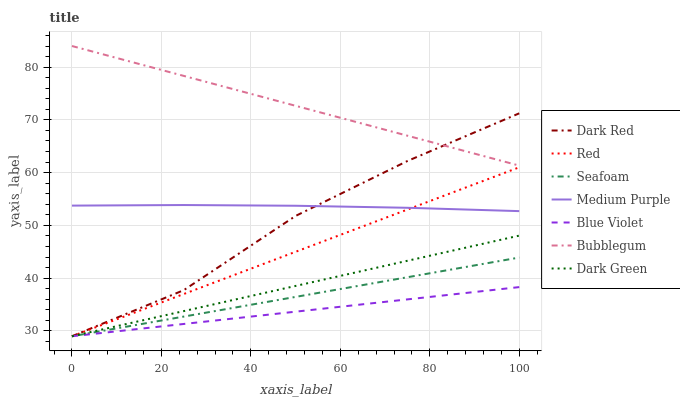Does Blue Violet have the minimum area under the curve?
Answer yes or no. Yes. Does Bubblegum have the maximum area under the curve?
Answer yes or no. Yes. Does Seafoam have the minimum area under the curve?
Answer yes or no. No. Does Seafoam have the maximum area under the curve?
Answer yes or no. No. Is Dark Green the smoothest?
Answer yes or no. Yes. Is Dark Red the roughest?
Answer yes or no. Yes. Is Seafoam the smoothest?
Answer yes or no. No. Is Seafoam the roughest?
Answer yes or no. No. Does Bubblegum have the lowest value?
Answer yes or no. No. Does Seafoam have the highest value?
Answer yes or no. No. Is Dark Green less than Medium Purple?
Answer yes or no. Yes. Is Medium Purple greater than Seafoam?
Answer yes or no. Yes. Does Dark Green intersect Medium Purple?
Answer yes or no. No. 